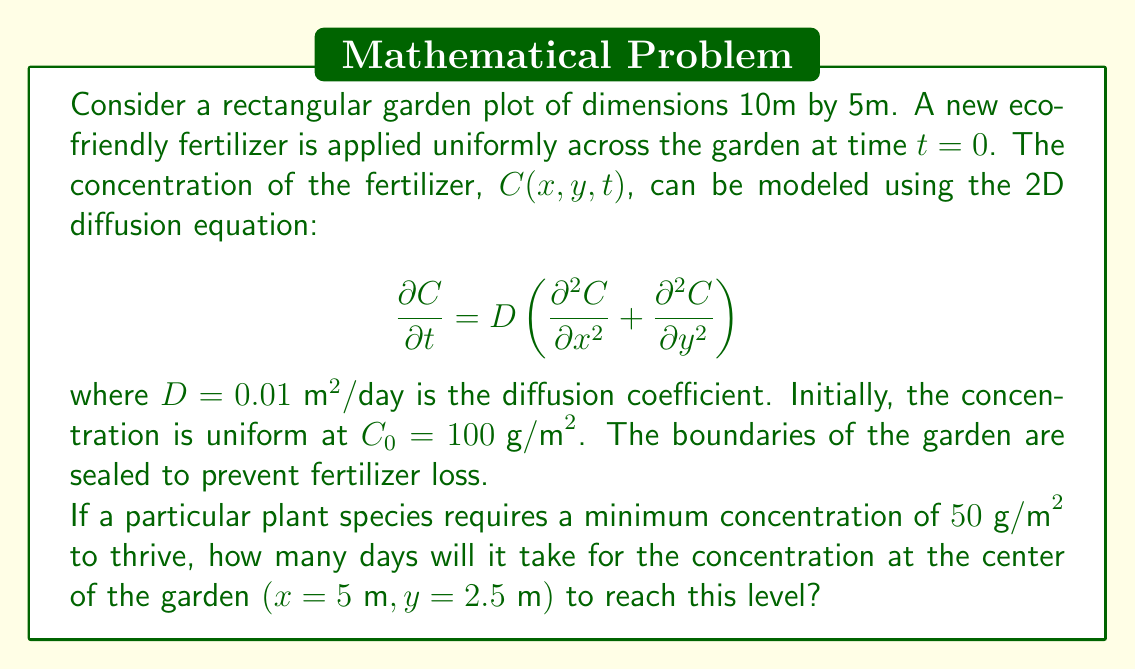Help me with this question. To solve this problem, we need to use the solution to the 2D diffusion equation with the given initial and boundary conditions. The solution for a rectangular domain with sealed boundaries is:

$$C(x,y,t) = C_0 \sum_{m=0}^{\infty} \sum_{n=0}^{\infty} \cos\left(\frac{m\pi x}{L_x}\right) \cos\left(\frac{n\pi y}{L_y}\right) e^{-D\pi^2t\left(\frac{m^2}{L_x^2}+\frac{n^2}{L_y^2}\right)}$$

where $L_x = 10\text{ m}$ and $L_y = 5\text{ m}$ are the dimensions of the garden.

At the center of the garden $(x=5\text{ m}, y=2.5\text{ m})$, we have:

$$C(5,2.5,t) = C_0 \sum_{m=0}^{\infty} \sum_{n=0}^{\infty} \cos\left(\frac{m\pi}{2}\right) \cos\left(\frac{n\pi}{2}\right) e^{-0.01\pi^2t\left(\frac{m^2}{100}+\frac{n^2}{25}\right)}$$

Due to the cosine terms, this sum simplifies to include only odd terms for both $m$ and $n$. The dominant term will be when $m=n=1$:

$$C(5,2.5,t) \approx C_0 e^{-0.01\pi^2t\left(\frac{1}{100}+\frac{1}{25}\right)} = 100 e^{-0.005\pi^2t}$$

We want to find $t$ when $C(5,2.5,t) = 50 \text{ g/m}^2$:

$$50 = 100 e^{-0.005\pi^2t}$$

Taking the natural logarithm of both sides:

$$\ln(0.5) = -0.005\pi^2t$$

Solving for $t$:

$$t = \frac{-\ln(0.5)}{0.005\pi^2} \approx 44.1 \text{ days}$$
Answer: It will take approximately 44 days for the concentration at the center of the garden to reach $50 \text{ g/m}^2$. 